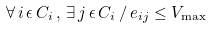<formula> <loc_0><loc_0><loc_500><loc_500>\forall \, i \, \epsilon \, C _ { i } \, , \, \exists \, j \, \epsilon \, C _ { i } \, / \, e _ { i j } \leq V _ { \max }</formula> 